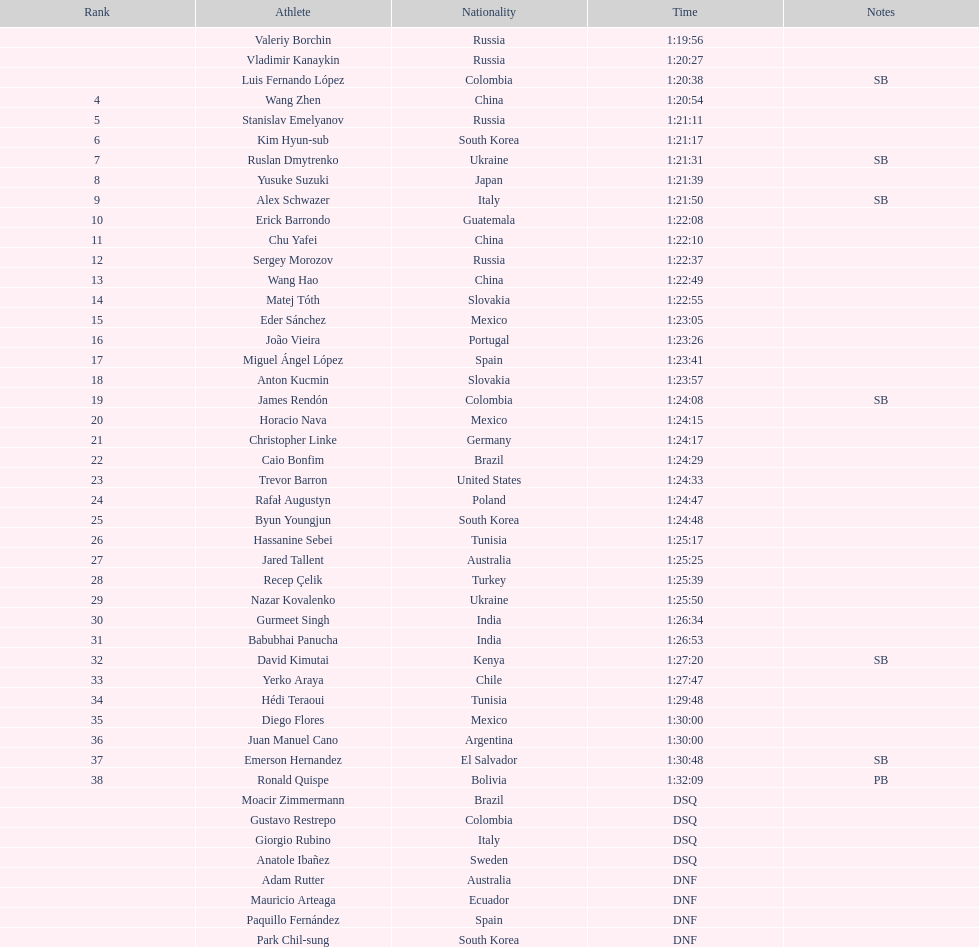How many russians achieved a minimum of 3rd position in the 20km walk? 2. 